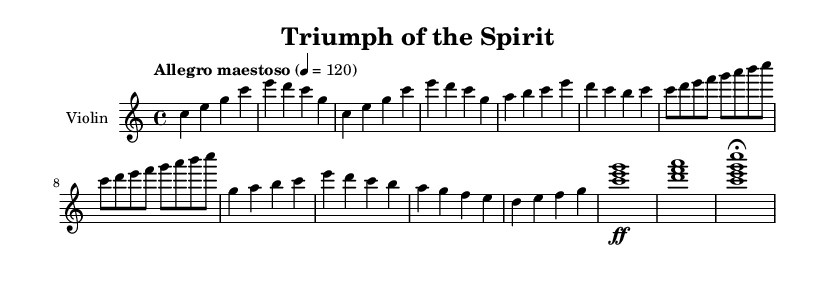What is the key signature of this music? The key signature is indicated at the beginning of the score, which is C major, shown by the absence of sharps or flats.
Answer: C major What is the time signature of this piece? The time signature is shown at the beginning of the score as 4/4, meaning there are four beats in each measure and the quarter note receives one beat.
Answer: 4/4 What is the tempo marking used in this score? The tempo marking is indicated in the score as "Allegro maestoso," which translates to a fast, majestic tempo.
Answer: Allegro maestoso How many measures contain the main theme 'A'? By counting the measures labeled as "Main Theme A," we find two lines with a total of 4 measures presenting this theme.
Answer: 4 What type of melodic movement predominantly appears in the bridge of the piece? The bridge contains a sequence of ascending notes which reflects a technique that creates tension and excitement, typical in orchestral pieces.
Answer: Ascending What is the dynamic marking at the climax? The climax of the piece features a dynamic marking of "ff," indicating that this section should be played very loudly to emphasize the peak moment of the music.
Answer: ff How does the ending of the piece conclude? The coda concludes with the marking "fermata," which indicates that the last chord should be held longer than its normal duration for dramatic effect.
Answer: fermata 